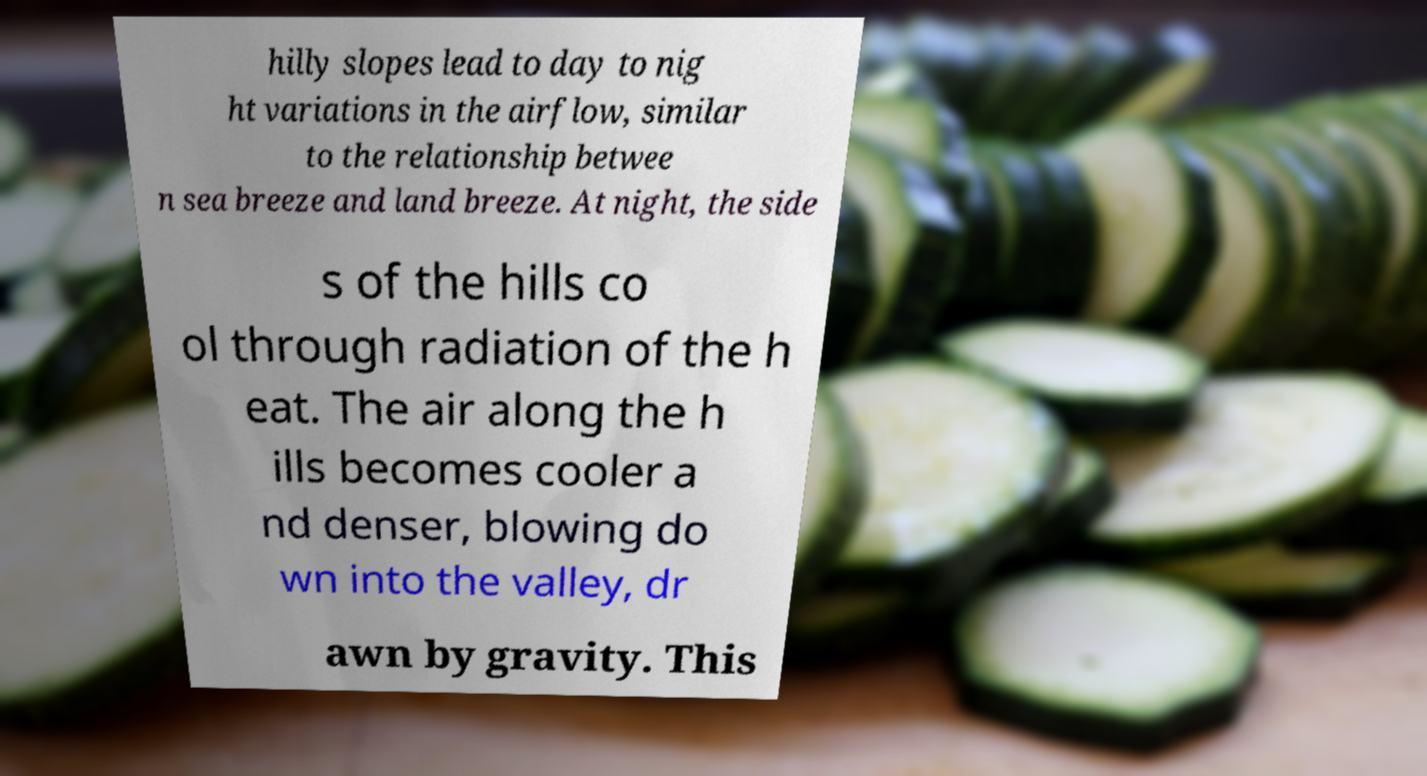Please read and relay the text visible in this image. What does it say? hilly slopes lead to day to nig ht variations in the airflow, similar to the relationship betwee n sea breeze and land breeze. At night, the side s of the hills co ol through radiation of the h eat. The air along the h ills becomes cooler a nd denser, blowing do wn into the valley, dr awn by gravity. This 